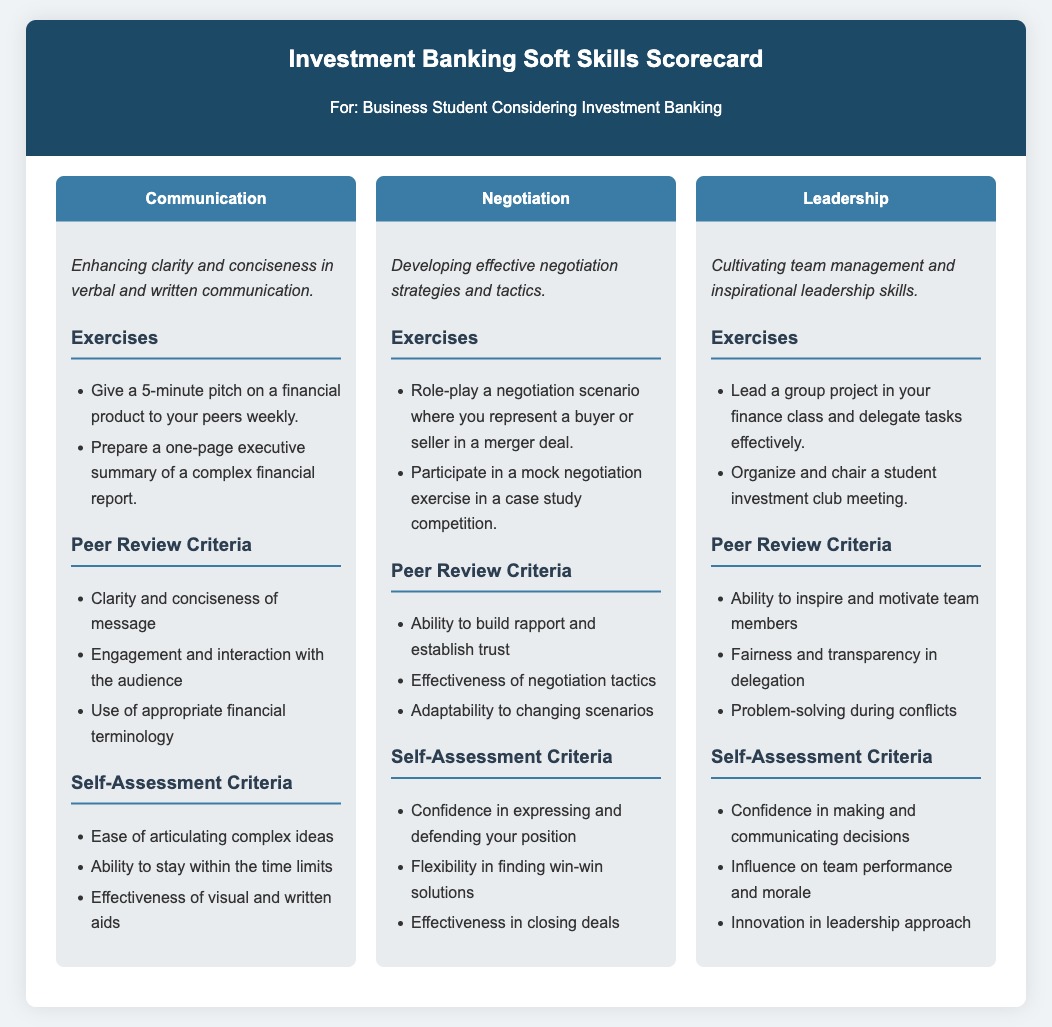What are the three key skills identified? The document identifies three key skills: Communication, Negotiation, and Leadership.
Answer: Communication, Negotiation, Leadership How often should a 5-minute pitch be given? The frequency for giving a 5-minute pitch is specified as weekly.
Answer: weekly What type of exercise involves role-playing a scenario? The exercise that involves role-playing is related to negotiation scenarios in a merger deal.
Answer: negotiation scenario What is one self-assessment criterion for communication? One of the self-assessment criteria for communication is "Ease of articulating complex ideas."
Answer: Ease of articulating complex ideas What should be prepared for a financial report? A one-page executive summary should be prepared for a complex financial report.
Answer: one-page executive summary Which skill focuses on team management? The skill that focuses on team management is Leadership.
Answer: Leadership In the peer review criteria for negotiation, what is essential for building rapport? The essential aspect in peer review criteria for negotiation is the ability to build rapport and establish trust.
Answer: ability to build rapport What is one exercise listed under leadership? An exercise listed under leadership is to "Lead a group project in your finance class."
Answer: Lead a group project in your finance class 